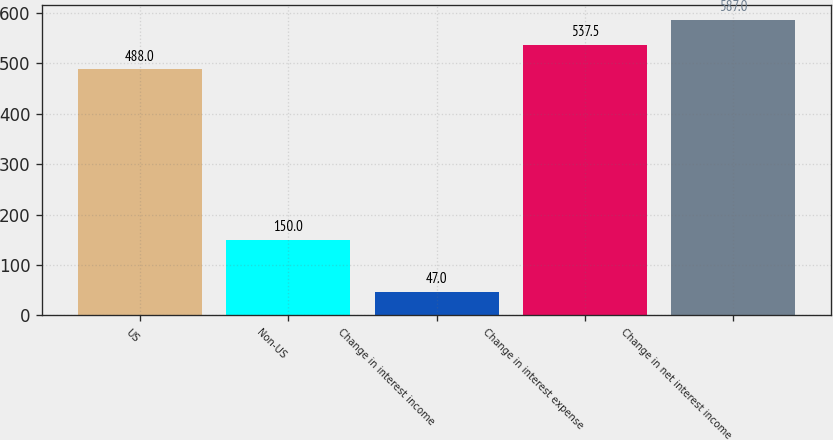Convert chart to OTSL. <chart><loc_0><loc_0><loc_500><loc_500><bar_chart><fcel>US<fcel>Non-US<fcel>Change in interest income<fcel>Change in interest expense<fcel>Change in net interest income<nl><fcel>488<fcel>150<fcel>47<fcel>537.5<fcel>587<nl></chart> 